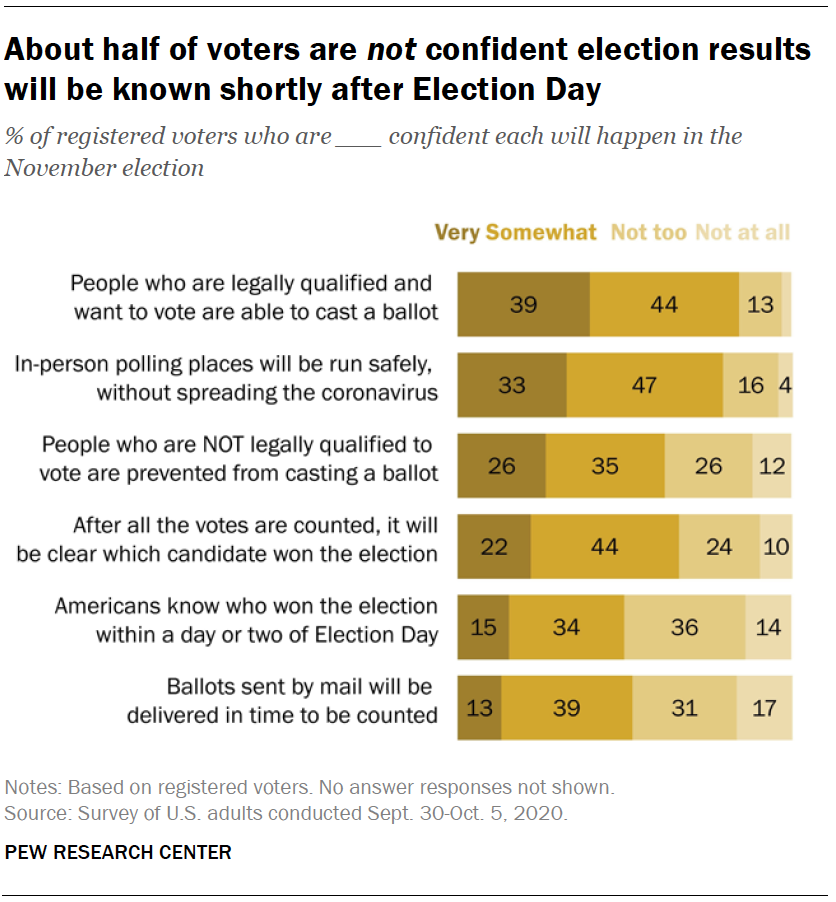Outline some significant characteristics in this image. What is the most frequently occurring value in the colored segments, specifically [13, 44]? The percentage of respondents who viewed the impact on the industry as 'not too' impacted in the bottom scenario, when divided by the percentage of respondents who viewed the impact as 'very somewhat' impacted, and then multiplied by 10, results in a value of 13. 